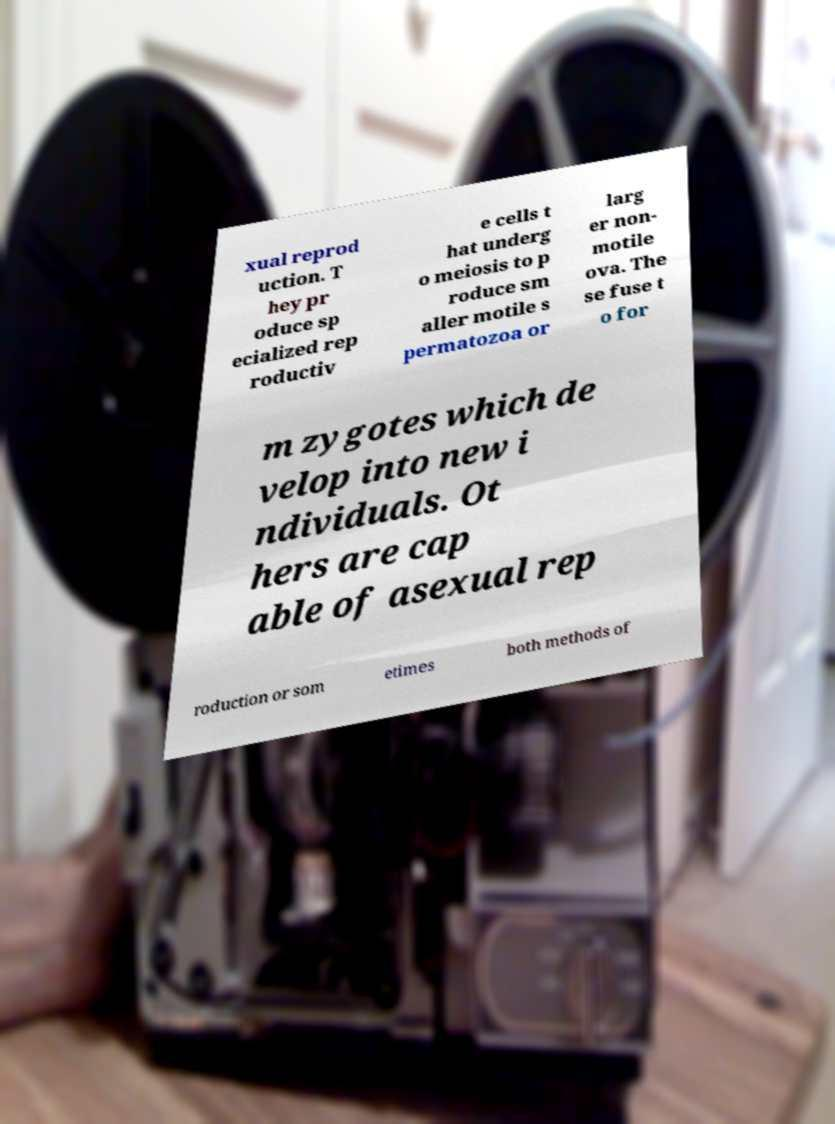There's text embedded in this image that I need extracted. Can you transcribe it verbatim? xual reprod uction. T hey pr oduce sp ecialized rep roductiv e cells t hat underg o meiosis to p roduce sm aller motile s permatozoa or larg er non- motile ova. The se fuse t o for m zygotes which de velop into new i ndividuals. Ot hers are cap able of asexual rep roduction or som etimes both methods of 